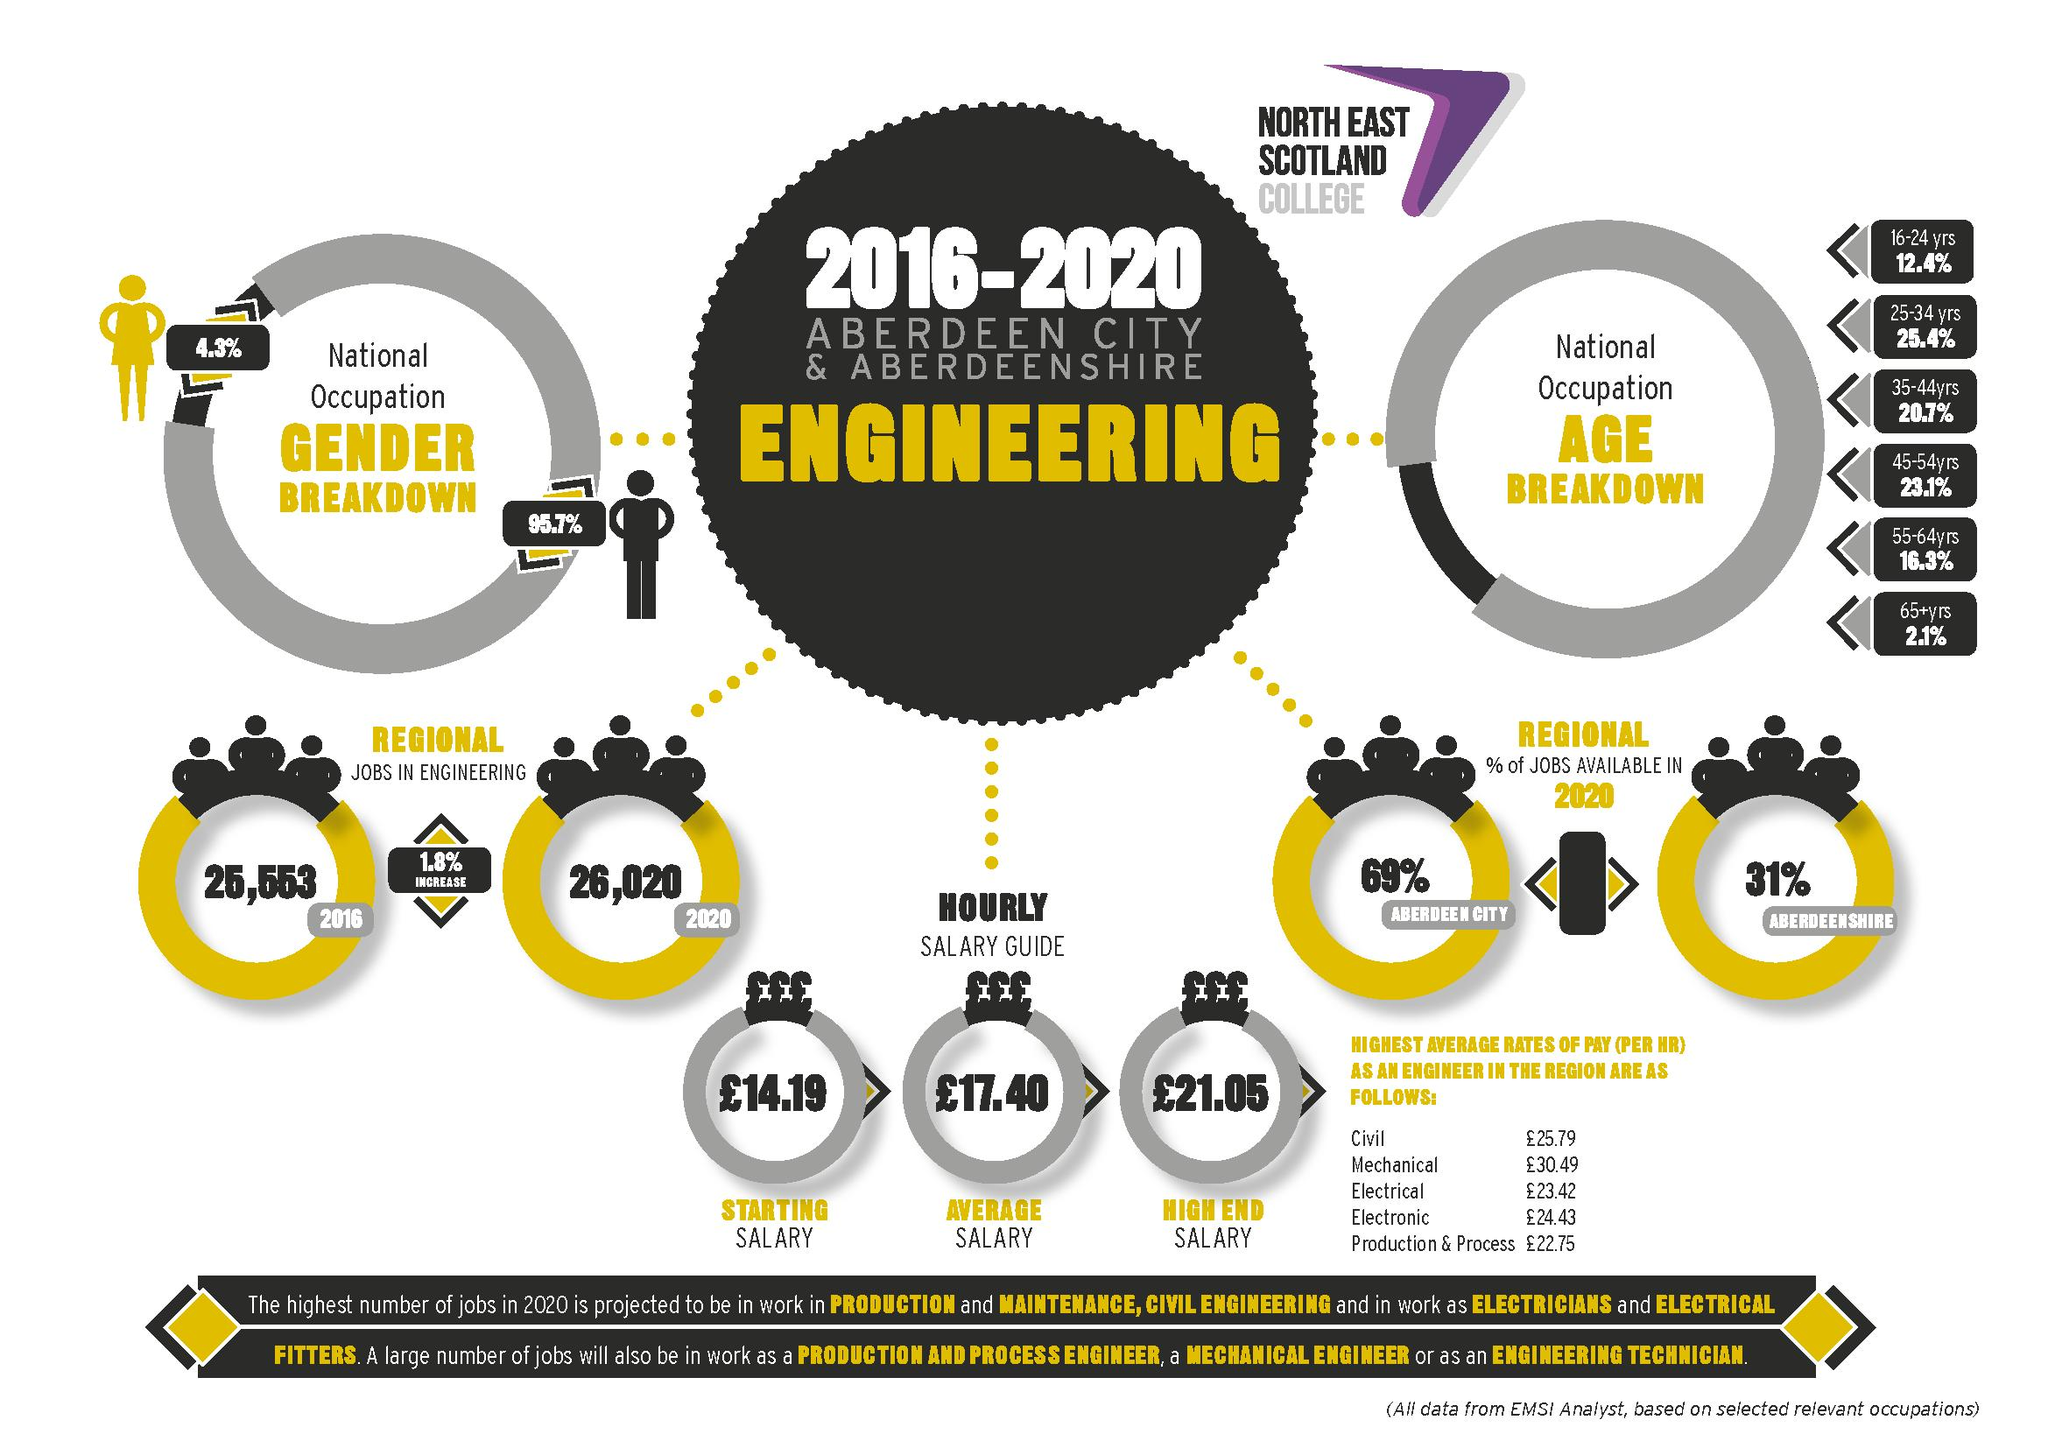Indicate a few pertinent items in this graphic. The average hourly salary is different from the starting hourly salary in pounds, with a difference of 3.21 pounds. According to recent data, the average rates of pay are higher in the mechanical sector compared to the civil sector. The percentage of jobs available in the Aberdeen shire that are higher than those available in Aberdeen city is greater. The table provides information on the average rate of pay for various sectors, with 5 sectors listed in total. In 2020, the number of regional engineering jobs was higher than in 2016. 